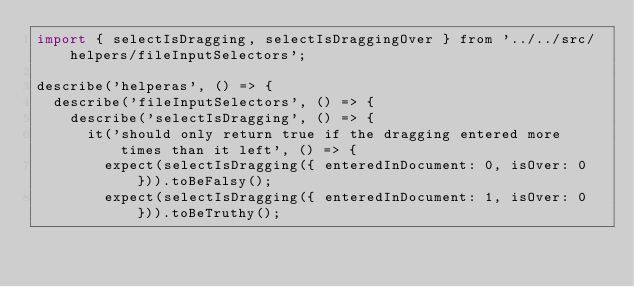Convert code to text. <code><loc_0><loc_0><loc_500><loc_500><_JavaScript_>import { selectIsDragging, selectIsDraggingOver } from '../../src/helpers/fileInputSelectors';

describe('helperas', () => {
  describe('fileInputSelectors', () => {
    describe('selectIsDragging', () => {
      it('should only return true if the dragging entered more times than it left', () => {
        expect(selectIsDragging({ enteredInDocument: 0, isOver: 0 })).toBeFalsy();
        expect(selectIsDragging({ enteredInDocument: 1, isOver: 0 })).toBeTruthy();</code> 